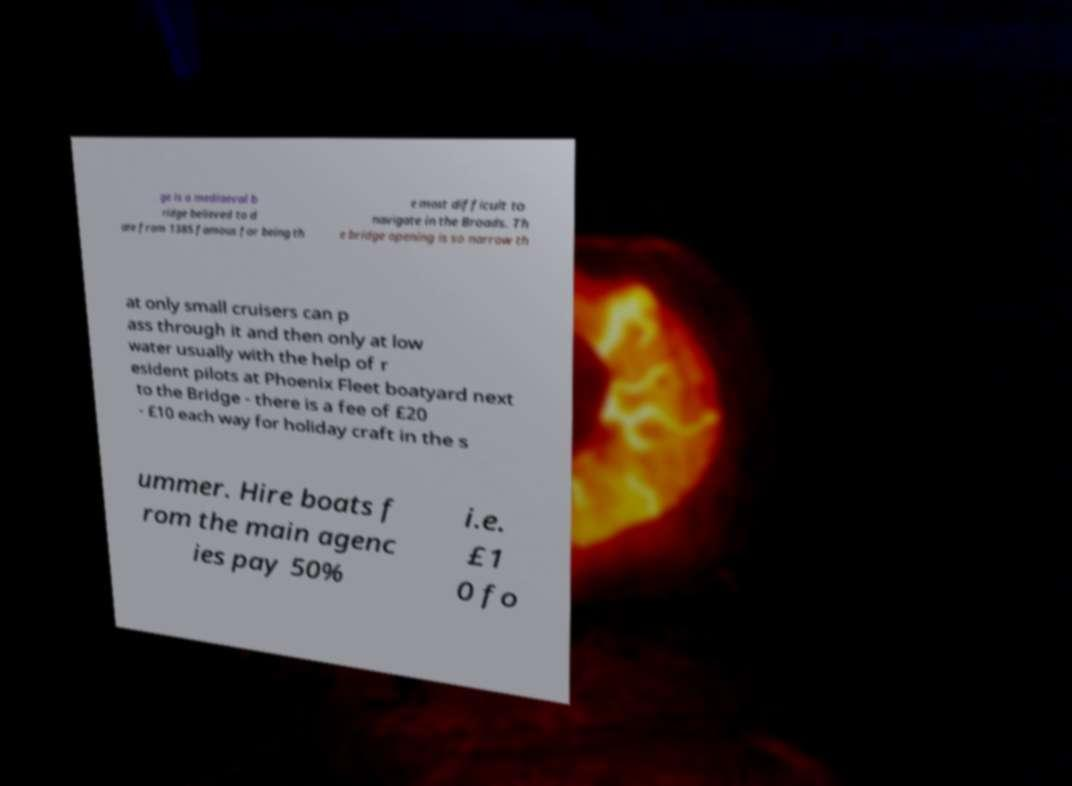I need the written content from this picture converted into text. Can you do that? ge is a mediaeval b ridge believed to d ate from 1385 famous for being th e most difficult to navigate in the Broads. Th e bridge opening is so narrow th at only small cruisers can p ass through it and then only at low water usually with the help of r esident pilots at Phoenix Fleet boatyard next to the Bridge - there is a fee of £20 - £10 each way for holiday craft in the s ummer. Hire boats f rom the main agenc ies pay 50% i.e. £1 0 fo 